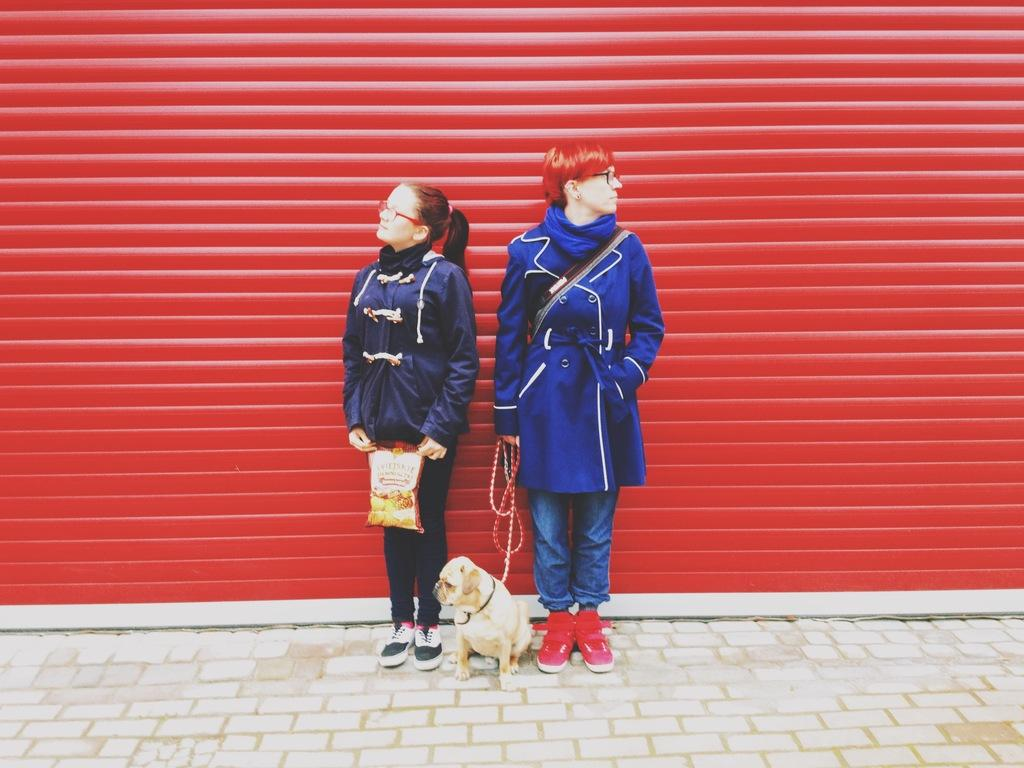How many people are in the image? There are two people in the image. What are the people holding in the image? The people are holding a puppy and a packet. What is the surface on which the people are standing? The people are standing on the ground. What can be seen in the background of the image? There is a red shutter in the background of the image. What type of metal is used to make the ornament on the puppy's collar in the image? There is no ornament or collar visible on the puppy in the image. 